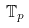<formula> <loc_0><loc_0><loc_500><loc_500>\mathbb { T } _ { p }</formula> 